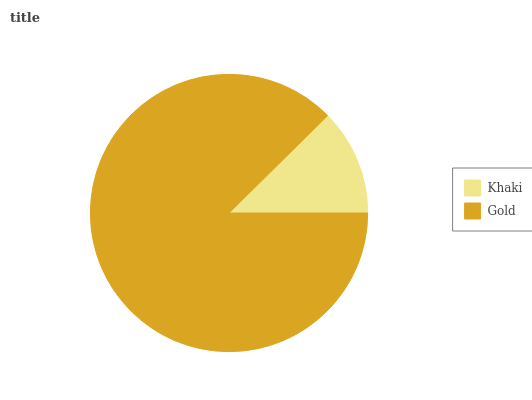Is Khaki the minimum?
Answer yes or no. Yes. Is Gold the maximum?
Answer yes or no. Yes. Is Gold the minimum?
Answer yes or no. No. Is Gold greater than Khaki?
Answer yes or no. Yes. Is Khaki less than Gold?
Answer yes or no. Yes. Is Khaki greater than Gold?
Answer yes or no. No. Is Gold less than Khaki?
Answer yes or no. No. Is Gold the high median?
Answer yes or no. Yes. Is Khaki the low median?
Answer yes or no. Yes. Is Khaki the high median?
Answer yes or no. No. Is Gold the low median?
Answer yes or no. No. 